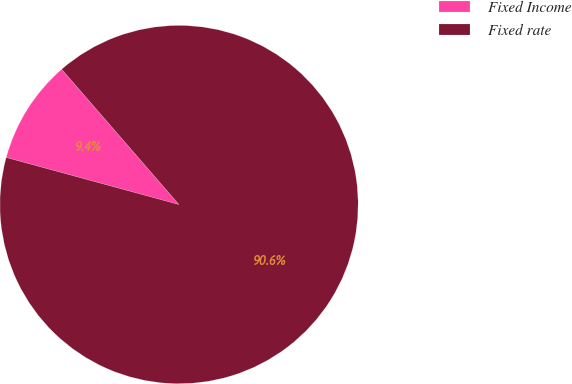<chart> <loc_0><loc_0><loc_500><loc_500><pie_chart><fcel>Fixed Income<fcel>Fixed rate<nl><fcel>9.4%<fcel>90.6%<nl></chart> 